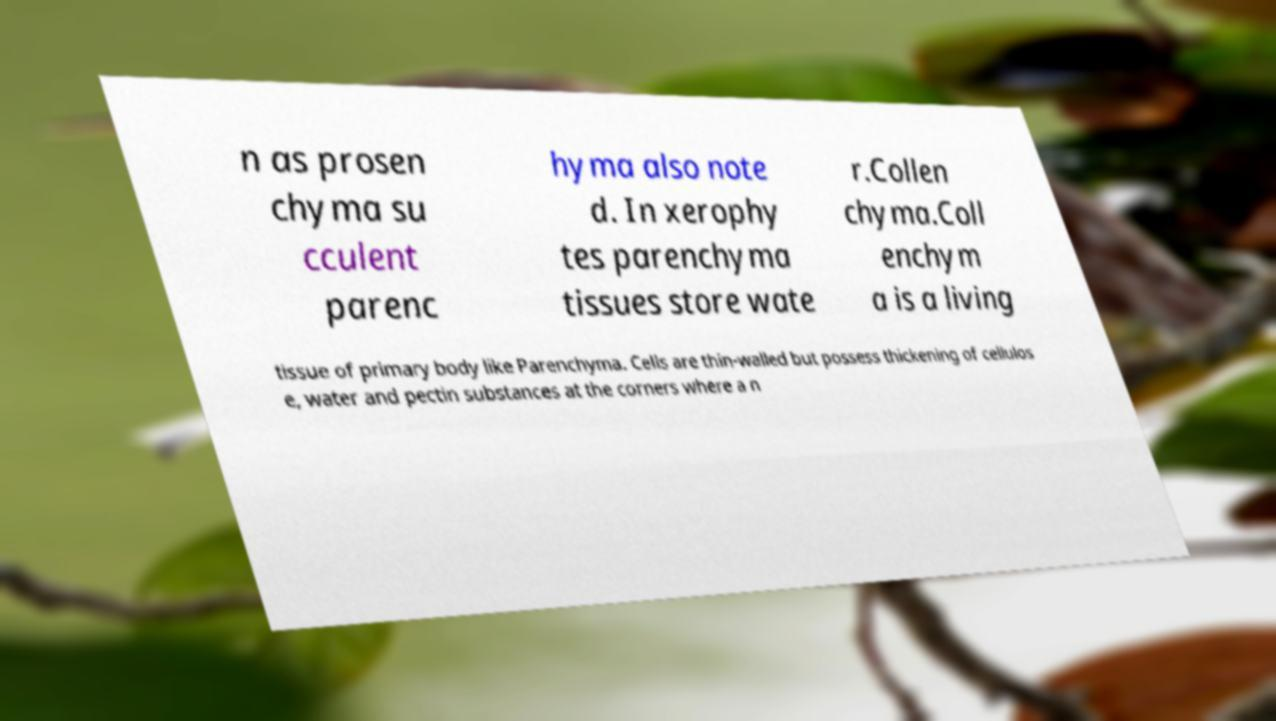For documentation purposes, I need the text within this image transcribed. Could you provide that? n as prosen chyma su cculent parenc hyma also note d. In xerophy tes parenchyma tissues store wate r.Collen chyma.Coll enchym a is a living tissue of primary body like Parenchyma. Cells are thin-walled but possess thickening of cellulos e, water and pectin substances at the corners where a n 